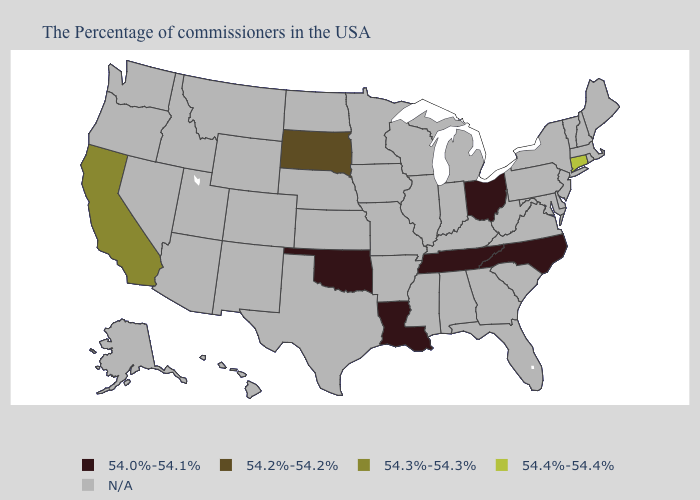Name the states that have a value in the range 54.4%-54.4%?
Be succinct. Connecticut. Name the states that have a value in the range 54.3%-54.3%?
Quick response, please. California. Name the states that have a value in the range 54.2%-54.2%?
Answer briefly. South Dakota. Name the states that have a value in the range 54.2%-54.2%?
Give a very brief answer. South Dakota. What is the value of New Hampshire?
Give a very brief answer. N/A. What is the value of Louisiana?
Quick response, please. 54.0%-54.1%. What is the value of Washington?
Give a very brief answer. N/A. What is the value of New Jersey?
Give a very brief answer. N/A. Name the states that have a value in the range 54.0%-54.1%?
Concise answer only. North Carolina, Ohio, Tennessee, Louisiana, Oklahoma. Name the states that have a value in the range 54.0%-54.1%?
Give a very brief answer. North Carolina, Ohio, Tennessee, Louisiana, Oklahoma. Which states have the highest value in the USA?
Be succinct. Connecticut. 